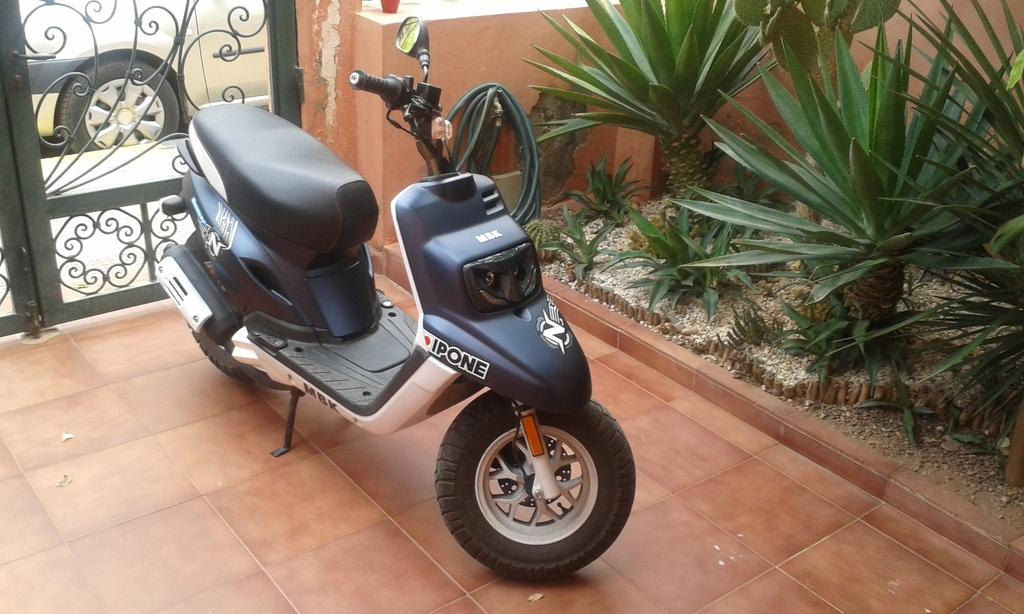What is parked on the floor in the image? There is a bike parked on the floor in the image. What can be seen on the right side of the image? There are plants on the right side of the image. What is located on the left side of the image? There is a gate on the left side of the image. What is visible behind the gate in the image? There is a car visible behind the gate in the image. What type of watch is the bike wearing in the image? Bikes do not wear watches, as they are inanimate objects. The bike in the image is not wearing a watch. 